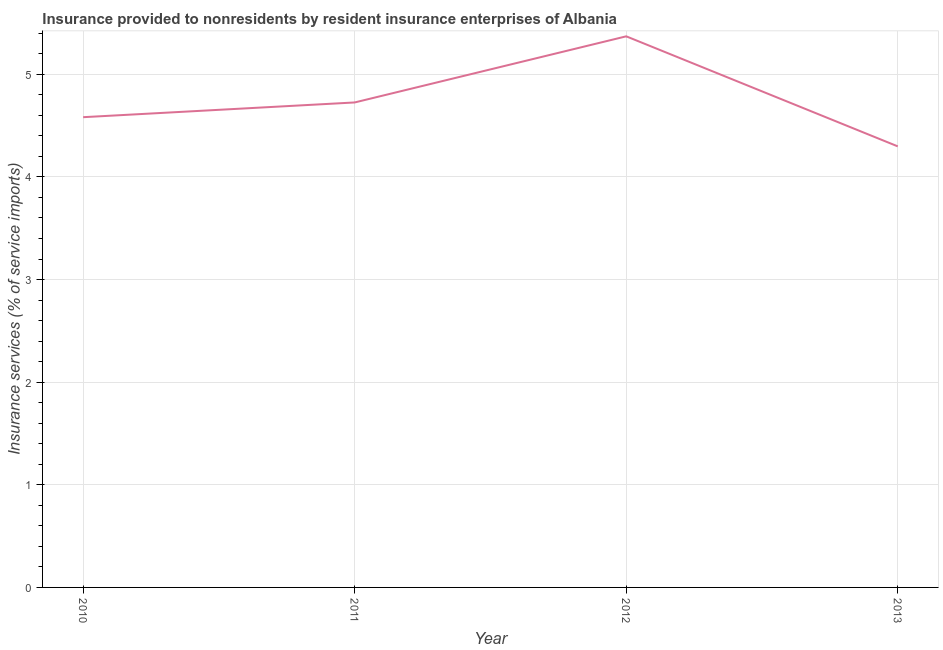What is the insurance and financial services in 2011?
Make the answer very short. 4.73. Across all years, what is the maximum insurance and financial services?
Your answer should be compact. 5.37. Across all years, what is the minimum insurance and financial services?
Your answer should be compact. 4.3. What is the sum of the insurance and financial services?
Keep it short and to the point. 18.98. What is the difference between the insurance and financial services in 2011 and 2013?
Provide a succinct answer. 0.43. What is the average insurance and financial services per year?
Keep it short and to the point. 4.74. What is the median insurance and financial services?
Keep it short and to the point. 4.65. What is the ratio of the insurance and financial services in 2010 to that in 2012?
Your answer should be very brief. 0.85. Is the difference between the insurance and financial services in 2010 and 2013 greater than the difference between any two years?
Ensure brevity in your answer.  No. What is the difference between the highest and the second highest insurance and financial services?
Your answer should be compact. 0.64. What is the difference between the highest and the lowest insurance and financial services?
Keep it short and to the point. 1.07. Does the insurance and financial services monotonically increase over the years?
Your answer should be compact. No. What is the difference between two consecutive major ticks on the Y-axis?
Keep it short and to the point. 1. Are the values on the major ticks of Y-axis written in scientific E-notation?
Your answer should be very brief. No. Does the graph contain grids?
Your answer should be very brief. Yes. What is the title of the graph?
Provide a short and direct response. Insurance provided to nonresidents by resident insurance enterprises of Albania. What is the label or title of the Y-axis?
Offer a terse response. Insurance services (% of service imports). What is the Insurance services (% of service imports) in 2010?
Make the answer very short. 4.58. What is the Insurance services (% of service imports) of 2011?
Your answer should be very brief. 4.73. What is the Insurance services (% of service imports) in 2012?
Ensure brevity in your answer.  5.37. What is the Insurance services (% of service imports) in 2013?
Ensure brevity in your answer.  4.3. What is the difference between the Insurance services (% of service imports) in 2010 and 2011?
Your answer should be compact. -0.14. What is the difference between the Insurance services (% of service imports) in 2010 and 2012?
Provide a short and direct response. -0.79. What is the difference between the Insurance services (% of service imports) in 2010 and 2013?
Your answer should be very brief. 0.28. What is the difference between the Insurance services (% of service imports) in 2011 and 2012?
Make the answer very short. -0.64. What is the difference between the Insurance services (% of service imports) in 2011 and 2013?
Keep it short and to the point. 0.43. What is the difference between the Insurance services (% of service imports) in 2012 and 2013?
Offer a terse response. 1.07. What is the ratio of the Insurance services (% of service imports) in 2010 to that in 2011?
Keep it short and to the point. 0.97. What is the ratio of the Insurance services (% of service imports) in 2010 to that in 2012?
Offer a very short reply. 0.85. What is the ratio of the Insurance services (% of service imports) in 2010 to that in 2013?
Your answer should be very brief. 1.07. What is the ratio of the Insurance services (% of service imports) in 2011 to that in 2012?
Provide a short and direct response. 0.88. What is the ratio of the Insurance services (% of service imports) in 2012 to that in 2013?
Your answer should be compact. 1.25. 